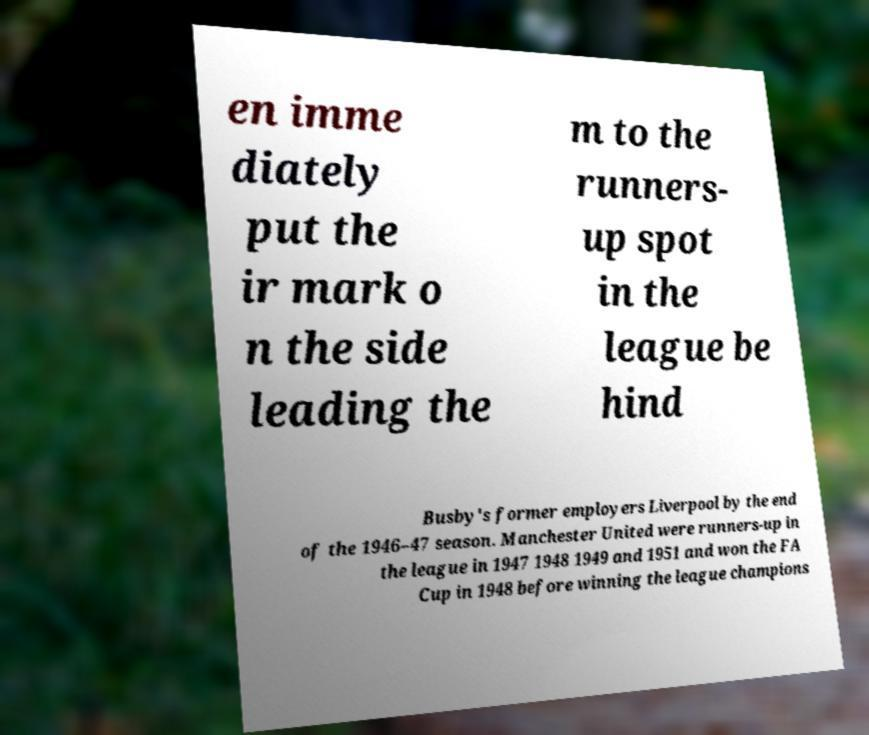I need the written content from this picture converted into text. Can you do that? en imme diately put the ir mark o n the side leading the m to the runners- up spot in the league be hind Busby's former employers Liverpool by the end of the 1946–47 season. Manchester United were runners-up in the league in 1947 1948 1949 and 1951 and won the FA Cup in 1948 before winning the league champions 